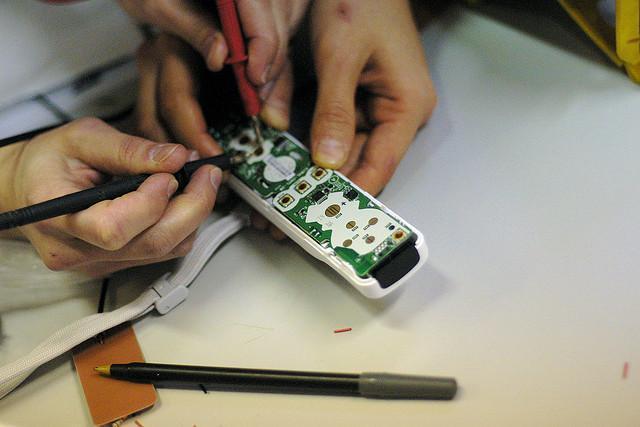How many people are visible?
Give a very brief answer. 2. 